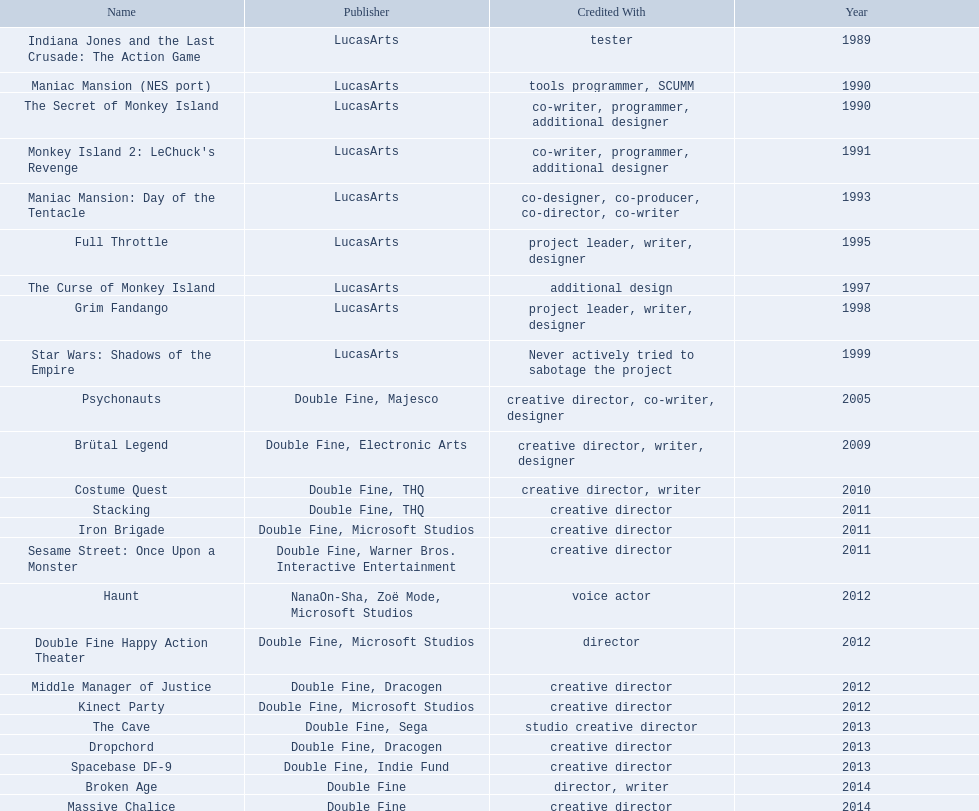What game name has tim schafer been involved with? Indiana Jones and the Last Crusade: The Action Game, Maniac Mansion (NES port), The Secret of Monkey Island, Monkey Island 2: LeChuck's Revenge, Maniac Mansion: Day of the Tentacle, Full Throttle, The Curse of Monkey Island, Grim Fandango, Star Wars: Shadows of the Empire, Psychonauts, Brütal Legend, Costume Quest, Stacking, Iron Brigade, Sesame Street: Once Upon a Monster, Haunt, Double Fine Happy Action Theater, Middle Manager of Justice, Kinect Party, The Cave, Dropchord, Spacebase DF-9, Broken Age, Massive Chalice. Which game has credit with just creative director? Creative director, creative director, creative director, creative director, creative director, creative director, creative director, creative director. Which games have the above and warner bros. interactive entertainment as publisher? Sesame Street: Once Upon a Monster. 